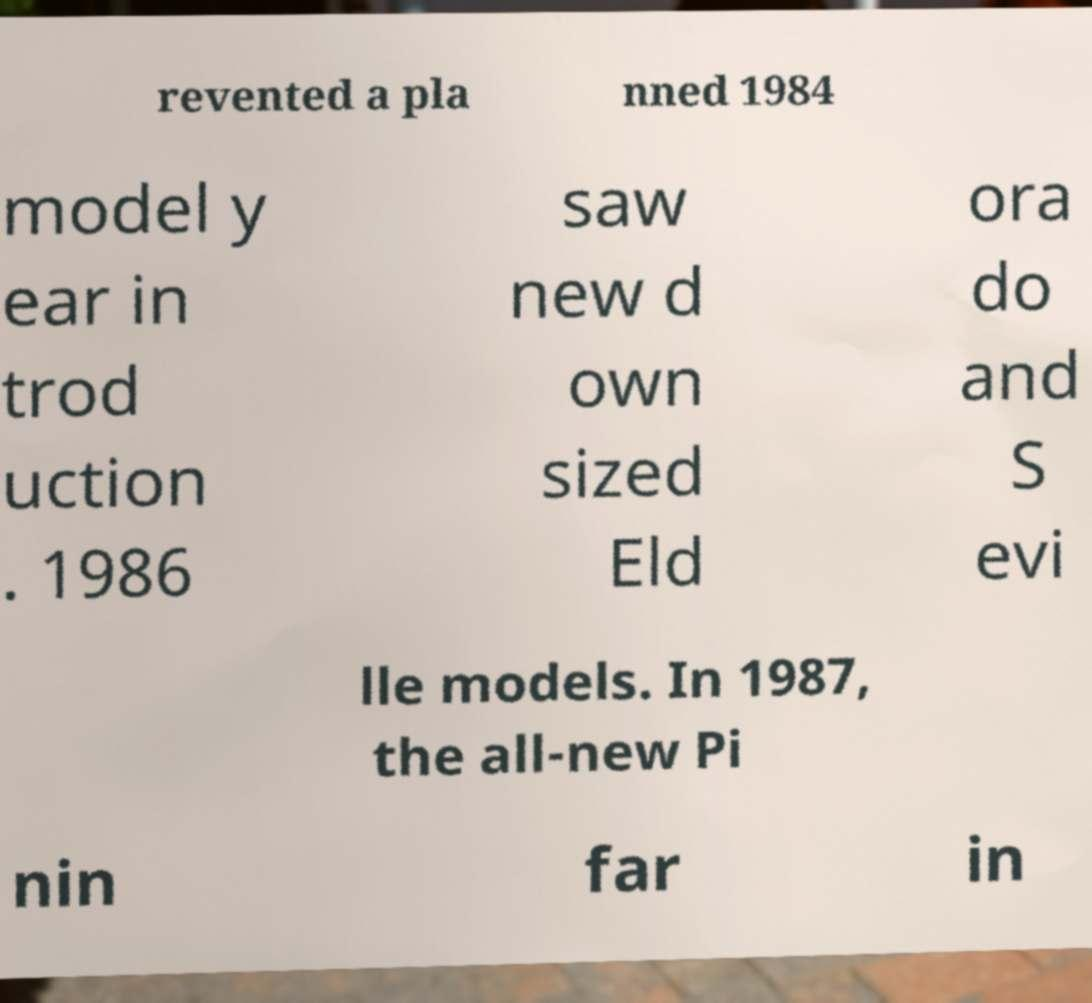Could you assist in decoding the text presented in this image and type it out clearly? revented a pla nned 1984 model y ear in trod uction . 1986 saw new d own sized Eld ora do and S evi lle models. In 1987, the all-new Pi nin far in 